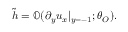Convert formula to latex. <formula><loc_0><loc_0><loc_500><loc_500>\tilde { h } = \mathbb { O } ( \partial _ { y } u _ { x } | _ { y = - 1 } ; \theta _ { O } ) .</formula> 